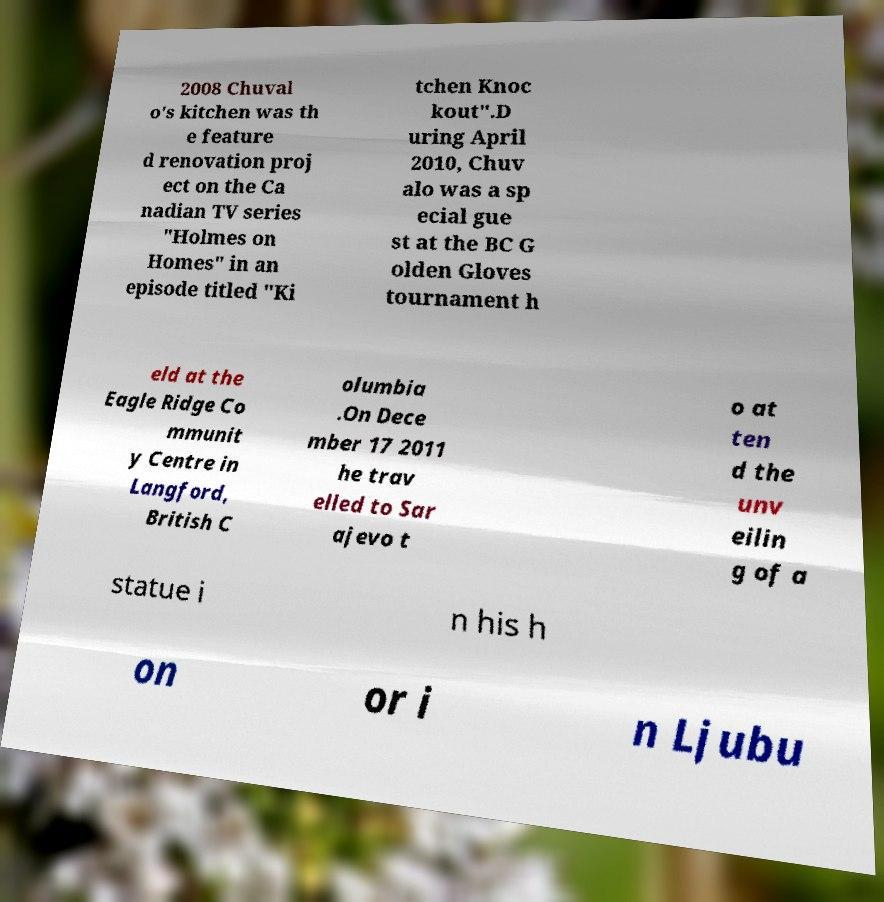Please identify and transcribe the text found in this image. 2008 Chuval o's kitchen was th e feature d renovation proj ect on the Ca nadian TV series "Holmes on Homes" in an episode titled "Ki tchen Knoc kout".D uring April 2010, Chuv alo was a sp ecial gue st at the BC G olden Gloves tournament h eld at the Eagle Ridge Co mmunit y Centre in Langford, British C olumbia .On Dece mber 17 2011 he trav elled to Sar ajevo t o at ten d the unv eilin g of a statue i n his h on or i n Ljubu 